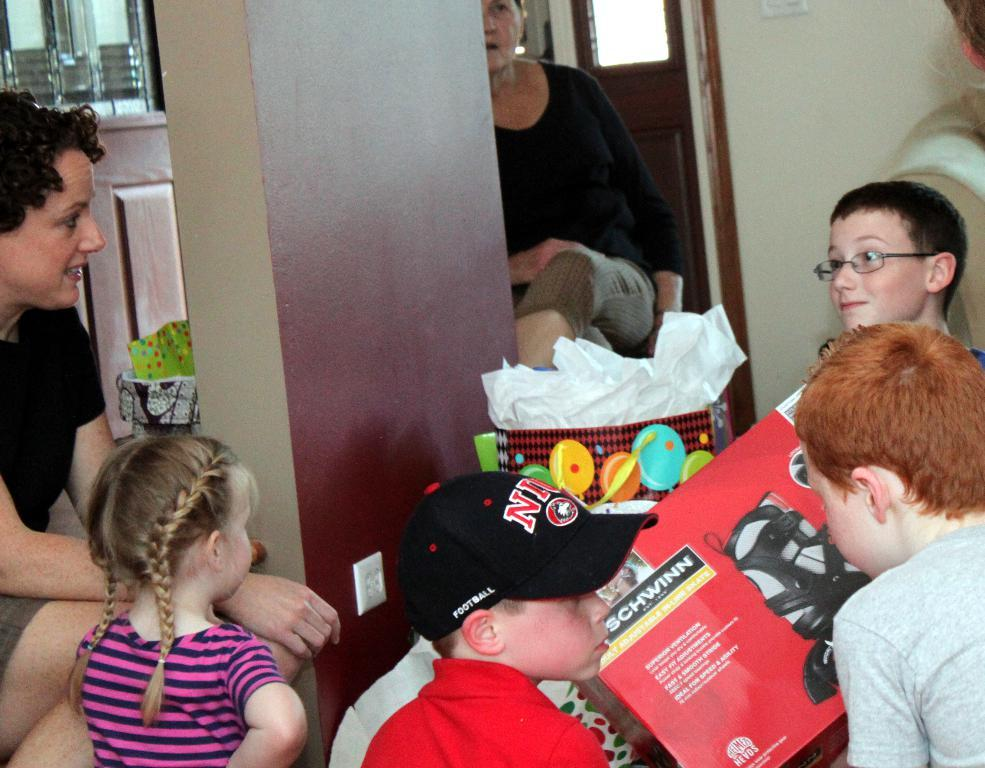What types of people are present in the image? There are women and kids in the image. Can you describe the clothing of one of the boys in the image? Yes, a boy is wearing a cap in the image. What is one of the kids holding in the image? Another boy is holding a book in the image. What type of curtain can be seen in the image? There is no curtain present in the image. What is the gate used for in the image? There is no gate present in the image. 